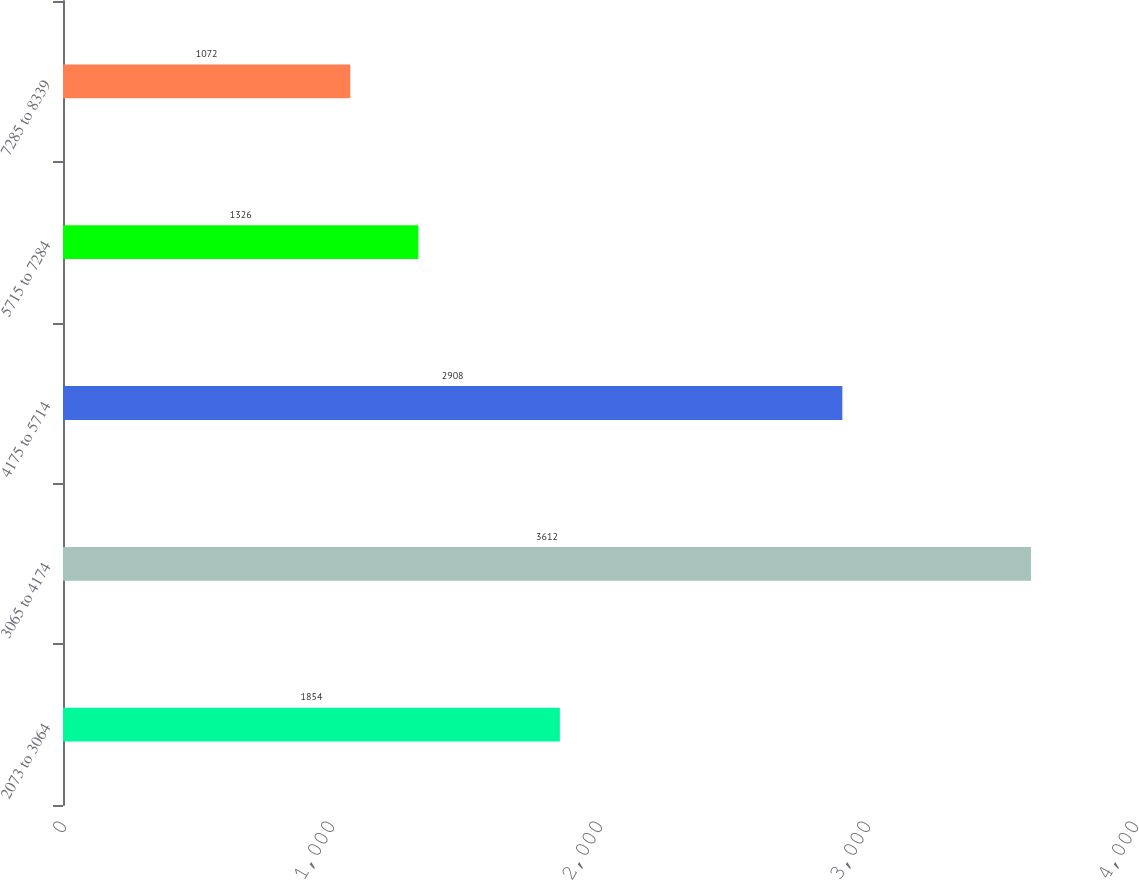Convert chart to OTSL. <chart><loc_0><loc_0><loc_500><loc_500><bar_chart><fcel>2073 to 3064<fcel>3065 to 4174<fcel>4175 to 5714<fcel>5715 to 7284<fcel>7285 to 8339<nl><fcel>1854<fcel>3612<fcel>2908<fcel>1326<fcel>1072<nl></chart> 